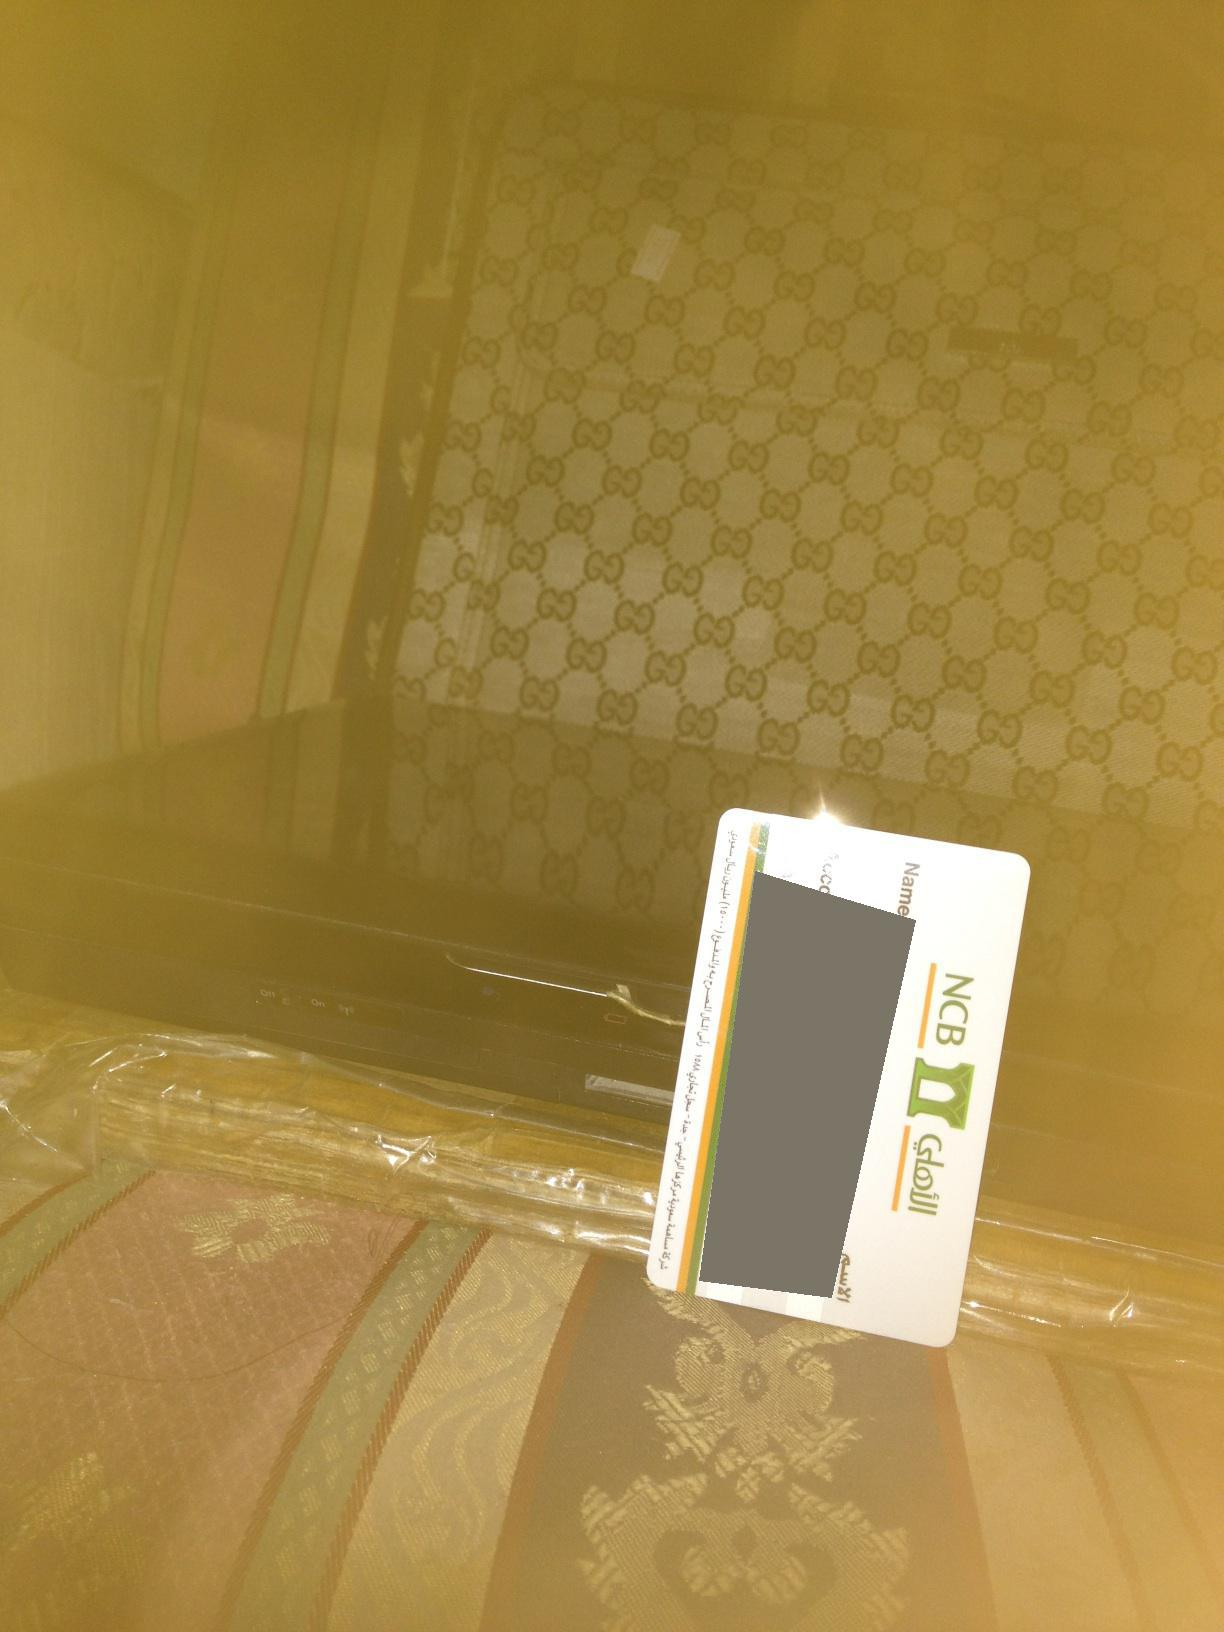Provide a realistic scenario of someone preparing to go on a business trip based on the items seen. The person is getting ready for a business trip. The branded suitcase indicates they travel frequently and prefer quality luggage. They’ve placed their corporate credit card on top of the suitcase while they organize their documents and electronic devices beneath the plastic wrap for protection. This equipment includes their laptop and possibly a tablet, crucial tools for their meetings and presentations. The careful arrangement of items and the selection of reliable travel gear suggest a meticulous and experienced traveler, planning efficiently to ensure a smooth and professional trip. 